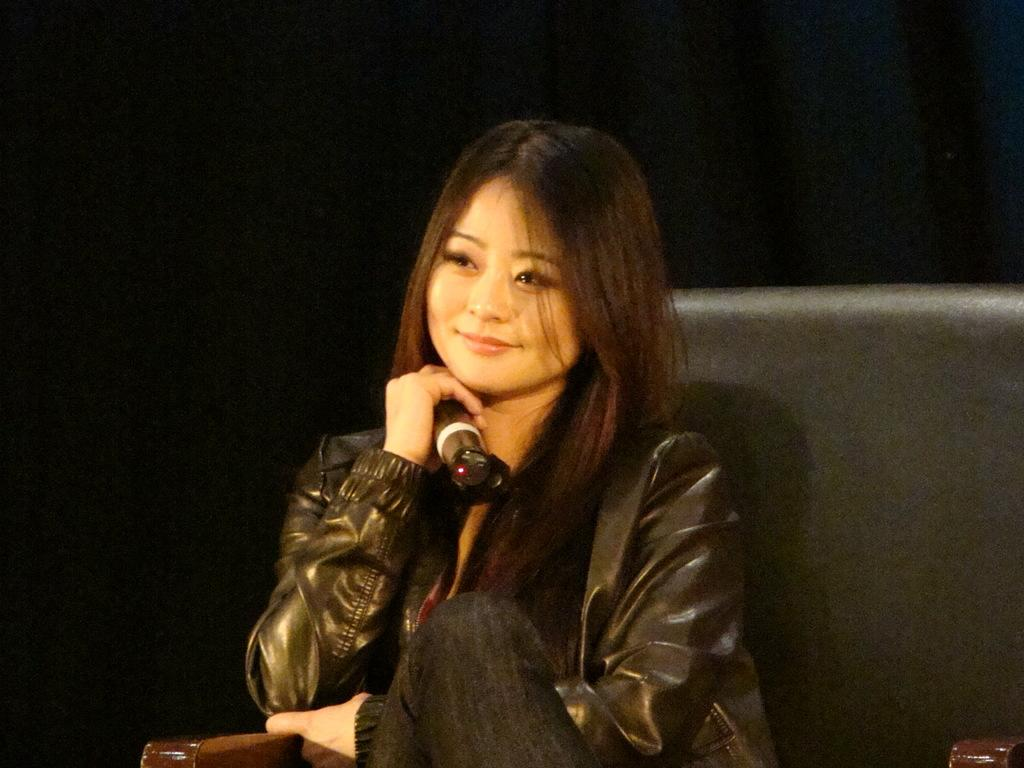Who is the main subject in the image? There is a woman in the center of the image. What is the woman doing in the image? The woman is sitting in a chair and holding a microphone. What can be seen in the background of the image? The background of the image is black. Can you see a toad making a statement in the image? There is no toad present in the image, nor is there any indication of a statement being made. 